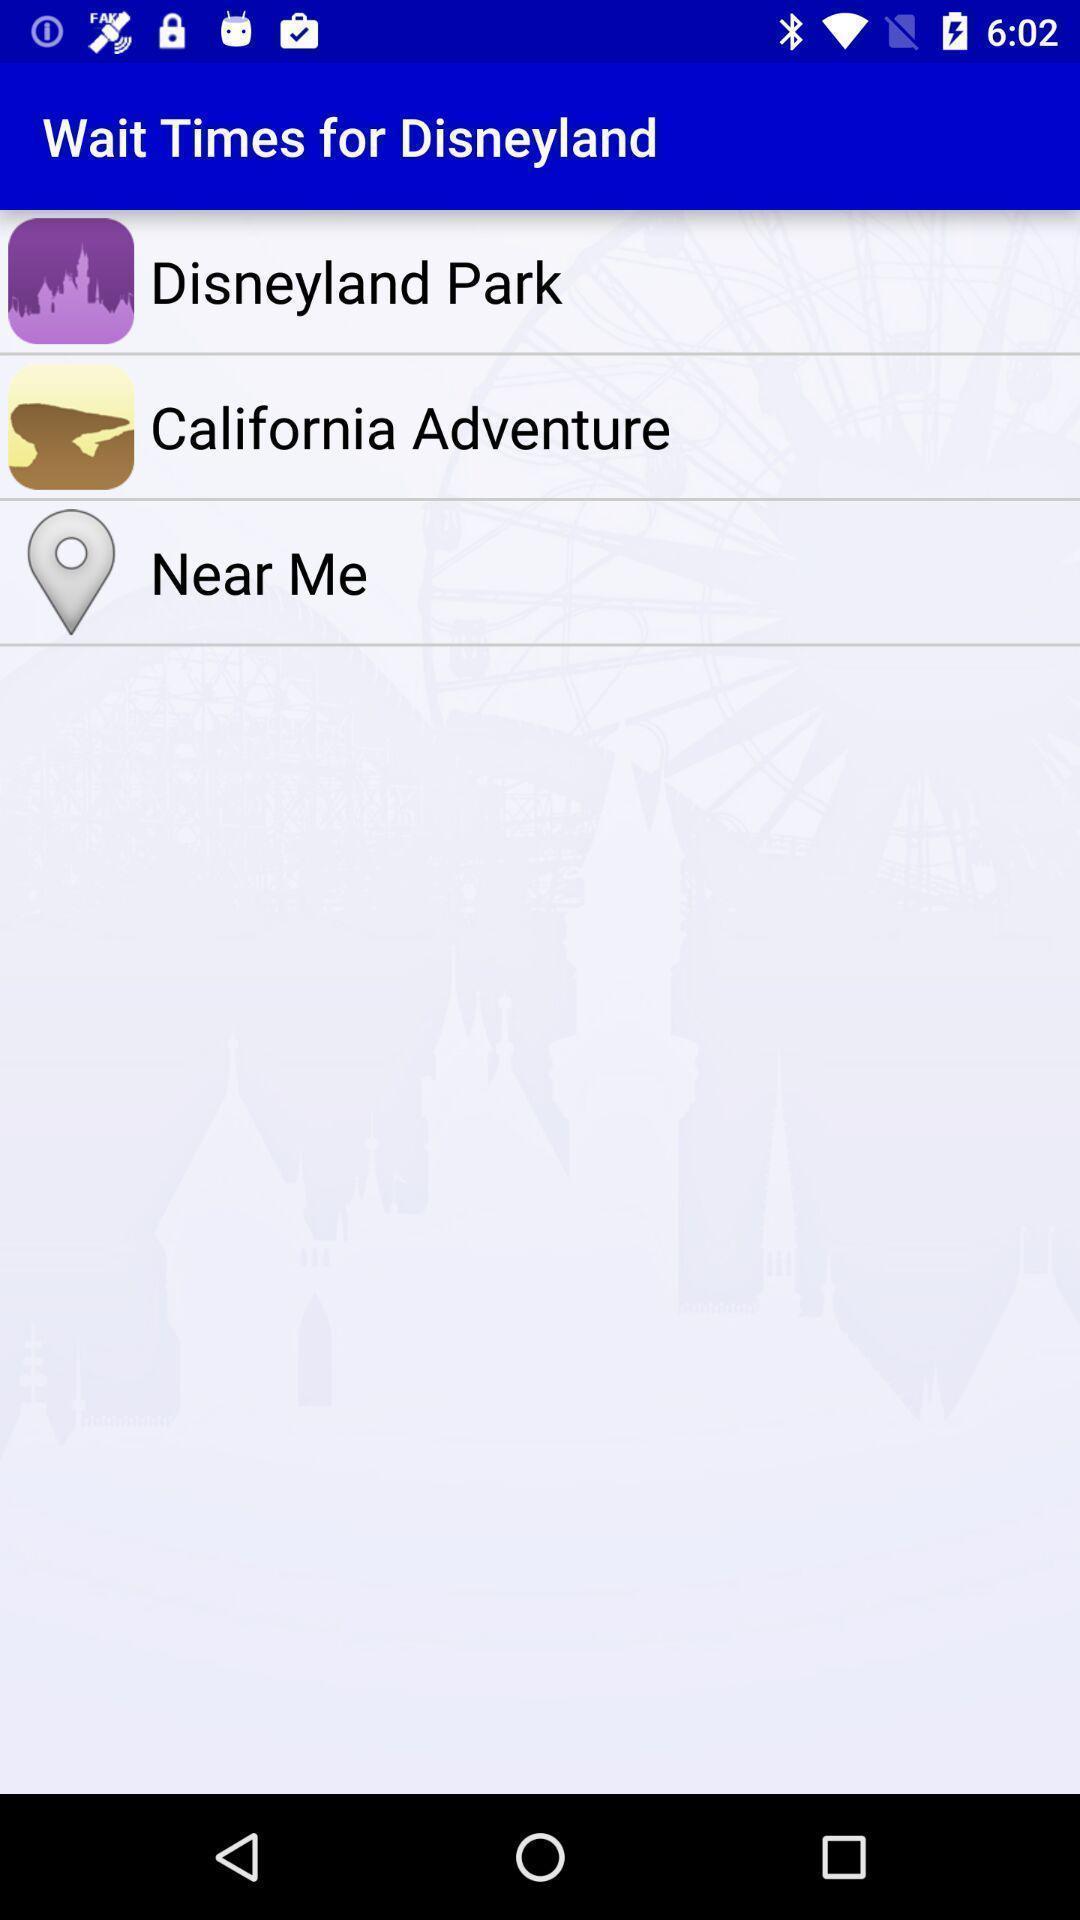Describe this image in words. Page displaying the wait times for disneyland. 